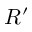Convert formula to latex. <formula><loc_0><loc_0><loc_500><loc_500>R ^ { \prime }</formula> 